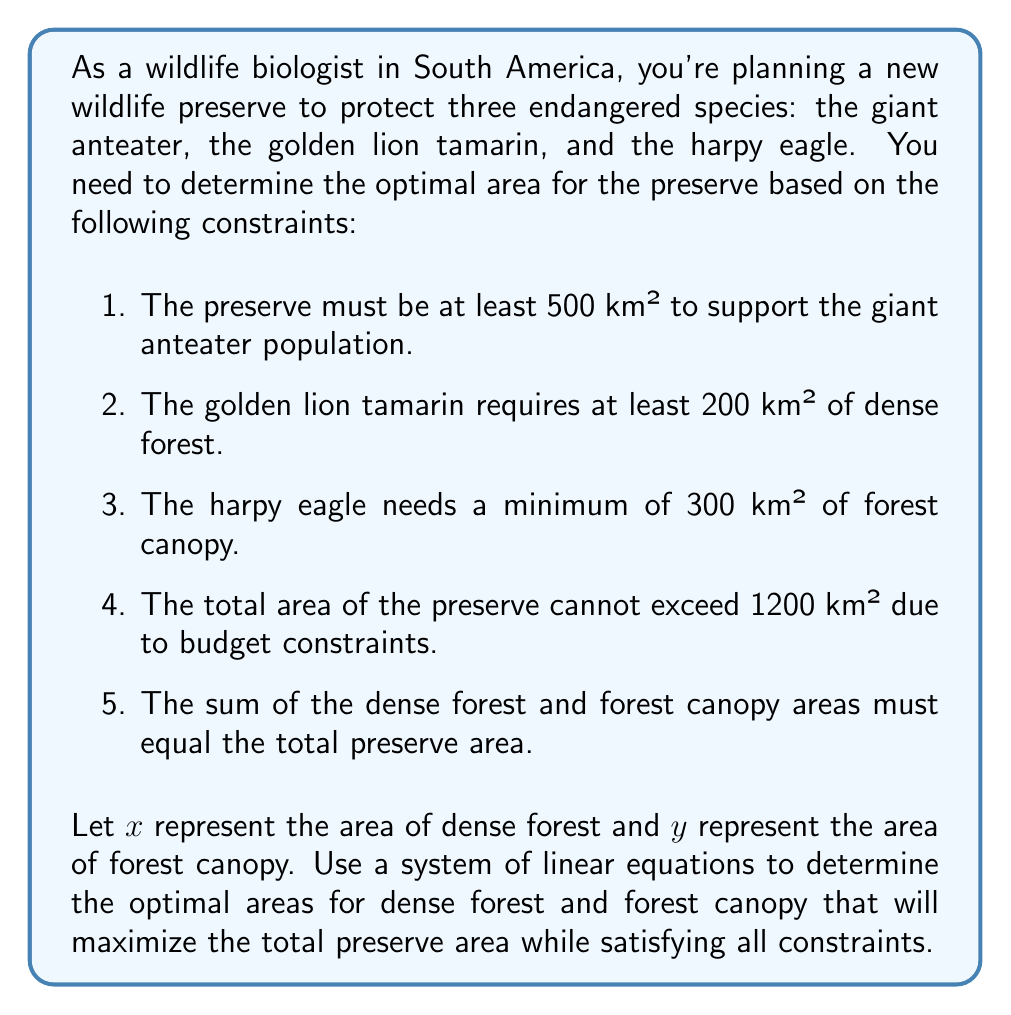Help me with this question. To solve this problem, we'll use a system of linear equations and inequalities based on the given constraints:

1. Total area constraint: $x + y \geq 500$ (for giant anteater)
2. Dense forest constraint: $x \geq 200$ (for golden lion tamarin)
3. Forest canopy constraint: $y \geq 300$ (for harpy eagle)
4. Maximum area constraint: $x + y \leq 1200$
5. Total area equation: $x + y = \text{total area}$

We want to maximize the total area while satisfying all constraints. The optimal solution will be at the intersection of the constraints.

Let's solve this graphically:

1. Plot the lines $x + y = 500$ and $x + y = 1200$
2. Plot the vertical line $x = 200$
3. Plot the horizontal line $y = 300$

The feasible region is the area bounded by these lines that satisfies all constraints.

[asy]
size(200,200);
import geometry;

// Define axes
draw((-50,0)--(250,0),arrow=Arrow(TeXHead));
draw((0,-50)--(0,250),arrow=Arrow(TeXHead));

// Label axes
label("$x$",(250,0),E);
label("$y$",(0,250),N);

// Plot constraints
draw((0,500)--(500,0),blue);
draw((0,1200)--(1200,0),red);
draw((200,0)--(200,1200),green);
draw((0,300)--(1200,300),purple);

// Shade feasible region
fill((200,300)--(200,900)--(900,300)--cycle,lightgray);

// Label points
label("(200,1000)",(200,1000),E);
label("(900,300)",(900,300),SE);
label("(200,300)",(200,300),SW);

// Label lines
label("$x + y = 500$",(250,250),NW,blue);
label("$x + y = 1200$",(600,600),NW,red);
label("$x = 200$",(200,-20),S,green);
label("$y = 300$",(-20,300),W,purple);
[/asy]

The optimal solution is at the intersection of $x = 200$ and $y = 900$, which satisfies all constraints and maximizes the total area.

To verify algebraically:

$$\begin{cases}
x = 200 \\
y = 1200 - 200 = 1000
\end{cases}$$

This solution satisfies all constraints:
1. $200 + 1000 = 1200 \geq 500$
2. $x = 200 \geq 200$
3. $y = 1000 \geq 300$
4. $200 + 1000 = 1200 \leq 1200$
5. $200 + 1000 = 1200$ (total area)

Therefore, the optimal solution is $x = 200$ km² of dense forest and $y = 1000$ km² of forest canopy, for a total preserve area of 1200 km².
Answer: The optimal area for the wildlife preserve is 1200 km², consisting of 200 km² of dense forest and 1000 km² of forest canopy. 